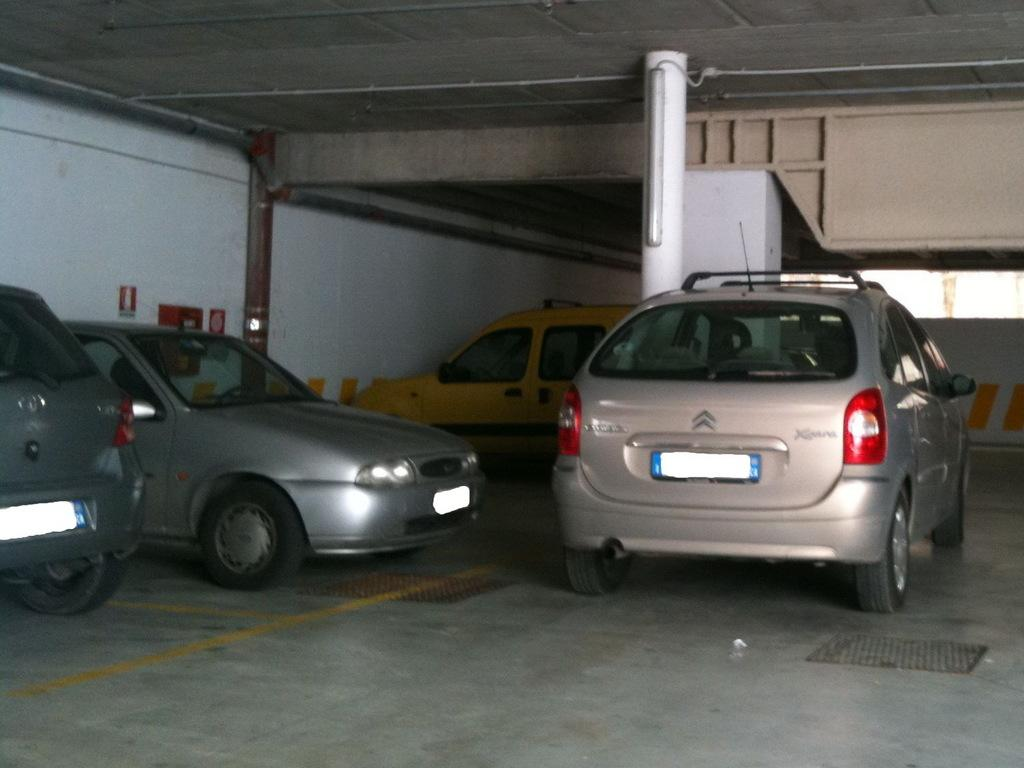What objects are on the floor in the image? There are cars on the floor in the image. What can be seen in the background of the image? There is a wall in the background of the image. What is visible at the top of the image? There is a roof visible at the top of the image. How many chickens are sitting on the cars in the image? There are no chickens present in the image; it features cars on the floor. What type of bird can be seen flying near the roof in the image? There are no birds visible in the image; it only shows cars on the floor, a wall in the background, and a roof at the top. 